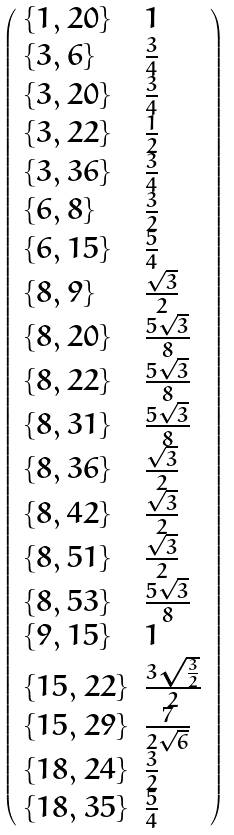<formula> <loc_0><loc_0><loc_500><loc_500>\left ( \begin{array} { l l } \{ 1 , 2 0 \} & 1 \\ \{ 3 , 6 \} & \frac { 3 } { 4 } \\ \{ 3 , 2 0 \} & \frac { 3 } { 4 } \\ \{ 3 , 2 2 \} & \frac { 1 } { 2 } \\ \{ 3 , 3 6 \} & \frac { 3 } { 4 } \\ \{ 6 , 8 \} & \frac { 3 } { 2 } \\ \{ 6 , 1 5 \} & \frac { 5 } { 4 } \\ \{ 8 , 9 \} & \frac { \sqrt { 3 } } { 2 } \\ \{ 8 , 2 0 \} & \frac { 5 \sqrt { 3 } } { 8 } \\ \{ 8 , 2 2 \} & \frac { 5 \sqrt { 3 } } { 8 } \\ \{ 8 , 3 1 \} & \frac { 5 \sqrt { 3 } } { 8 } \\ \{ 8 , 3 6 \} & \frac { \sqrt { 3 } } { 2 } \\ \{ 8 , 4 2 \} & \frac { \sqrt { 3 } } { 2 } \\ \{ 8 , 5 1 \} & \frac { \sqrt { 3 } } { 2 } \\ \{ 8 , 5 3 \} & \frac { 5 \sqrt { 3 } } { 8 } \\ \{ 9 , 1 5 \} & 1 \\ \{ 1 5 , 2 2 \} & \frac { 3 \sqrt { \frac { 3 } { 2 } } } { 2 } \\ \{ 1 5 , 2 9 \} & \frac { 7 } { 2 \sqrt { 6 } } \\ \{ 1 8 , 2 4 \} & \frac { 3 } { 2 } \\ \{ 1 8 , 3 5 \} & \frac { 5 } { 4 } \end{array} \right )</formula> 